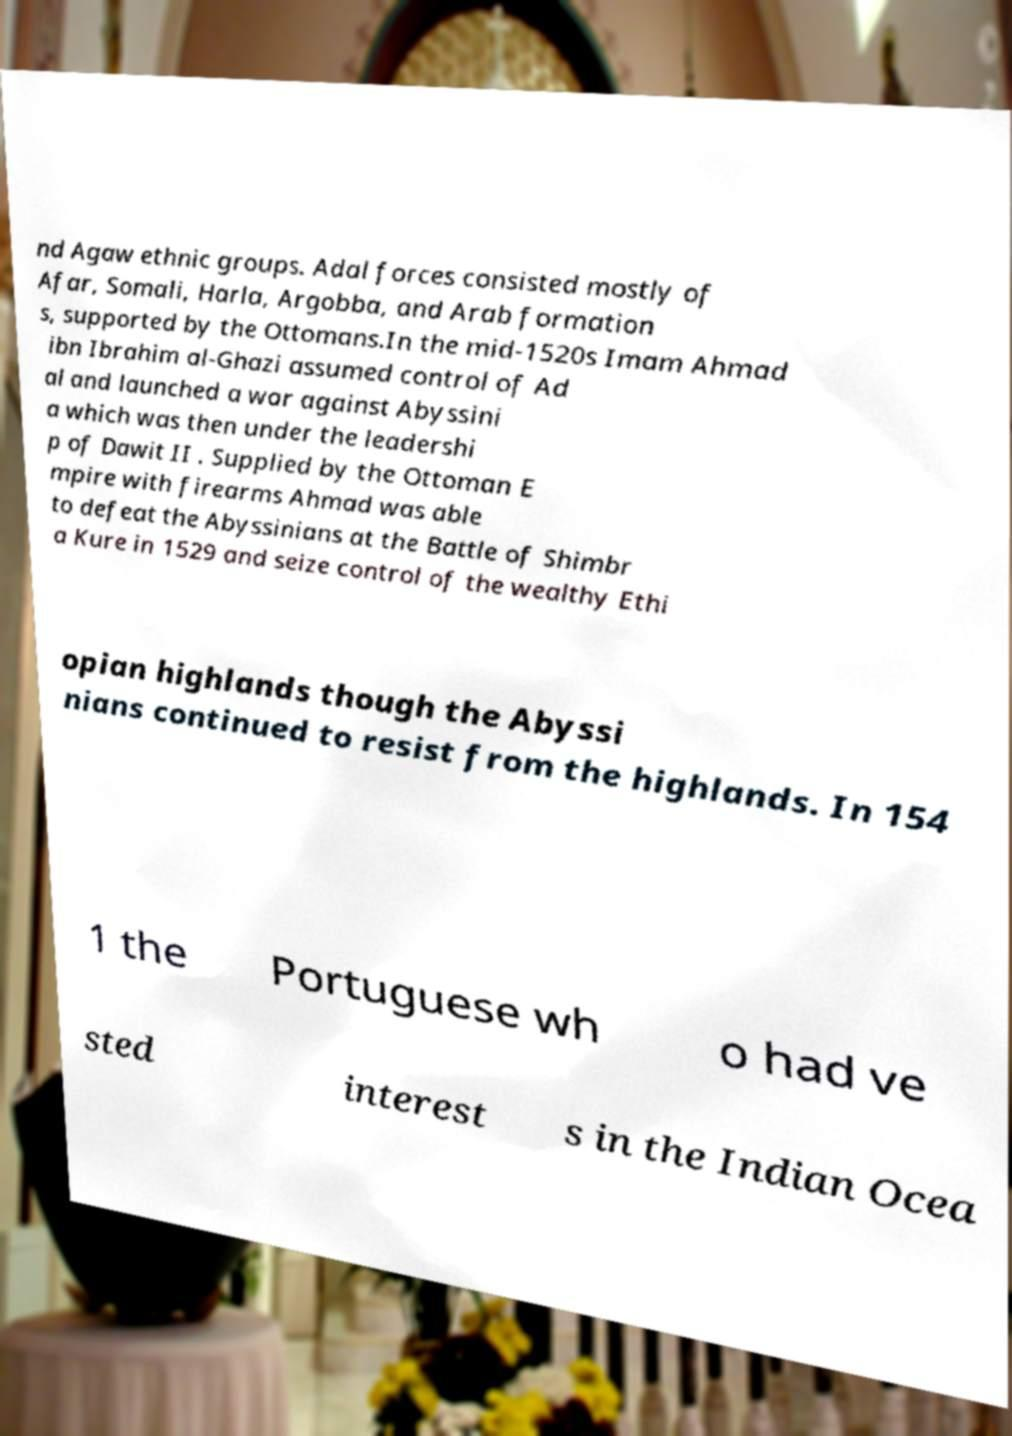Could you extract and type out the text from this image? nd Agaw ethnic groups. Adal forces consisted mostly of Afar, Somali, Harla, Argobba, and Arab formation s, supported by the Ottomans.In the mid-1520s Imam Ahmad ibn Ibrahim al-Ghazi assumed control of Ad al and launched a war against Abyssini a which was then under the leadershi p of Dawit II . Supplied by the Ottoman E mpire with firearms Ahmad was able to defeat the Abyssinians at the Battle of Shimbr a Kure in 1529 and seize control of the wealthy Ethi opian highlands though the Abyssi nians continued to resist from the highlands. In 154 1 the Portuguese wh o had ve sted interest s in the Indian Ocea 